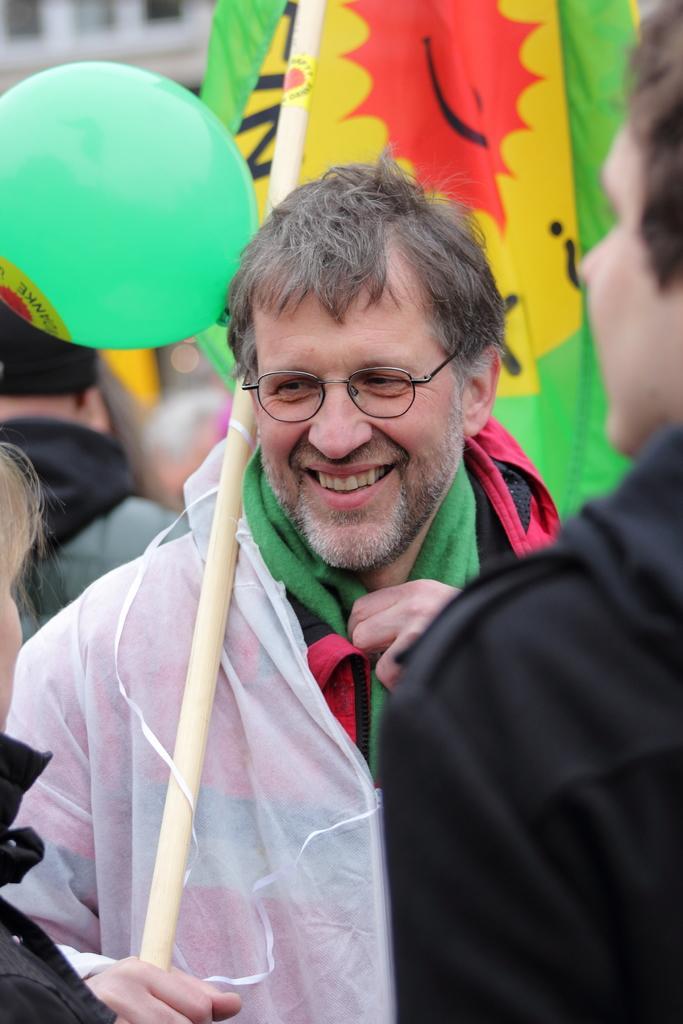Can you describe this image briefly? In this picture there is a man who is standing in the center of the image, by holding a flag and a balloon in his hand and there are other people on the right and left side of the image. 